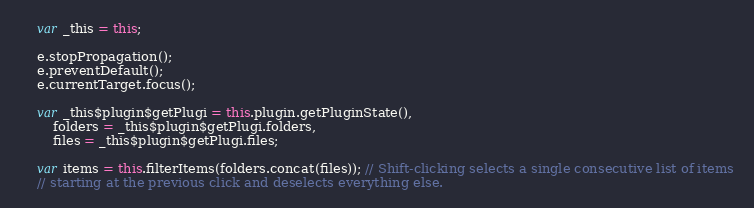<code> <loc_0><loc_0><loc_500><loc_500><_JavaScript_>    var _this = this;

    e.stopPropagation();
    e.preventDefault();
    e.currentTarget.focus();

    var _this$plugin$getPlugi = this.plugin.getPluginState(),
        folders = _this$plugin$getPlugi.folders,
        files = _this$plugin$getPlugi.files;

    var items = this.filterItems(folders.concat(files)); // Shift-clicking selects a single consecutive list of items
    // starting at the previous click and deselects everything else.
</code> 